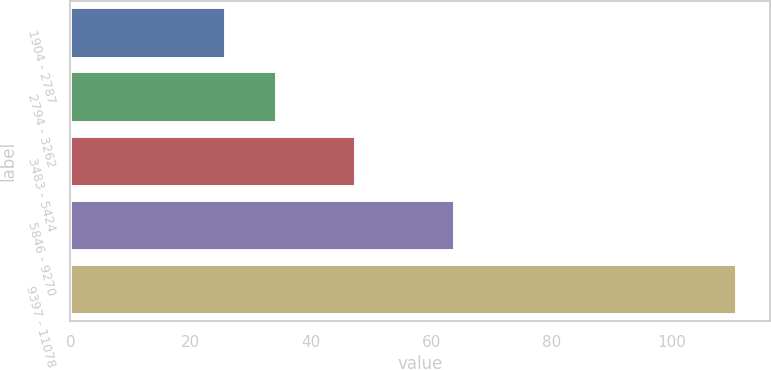<chart> <loc_0><loc_0><loc_500><loc_500><bar_chart><fcel>1904 - 2787<fcel>2794 - 3262<fcel>3483 - 5424<fcel>5846 - 9270<fcel>9397 - 11078<nl><fcel>25.91<fcel>34.4<fcel>47.39<fcel>63.85<fcel>110.78<nl></chart> 